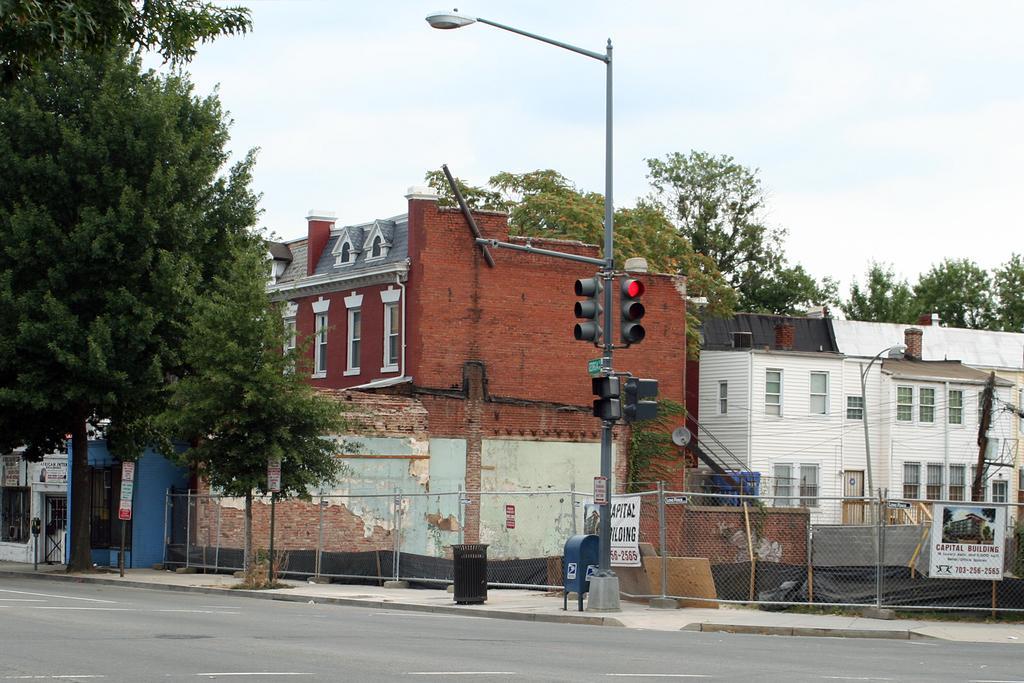Could you give a brief overview of what you see in this image? In this image I can see a building which is in brown color, in front I can see a traffic signal, a light pole, at left and right I can see trees in green color and sky in white color. 